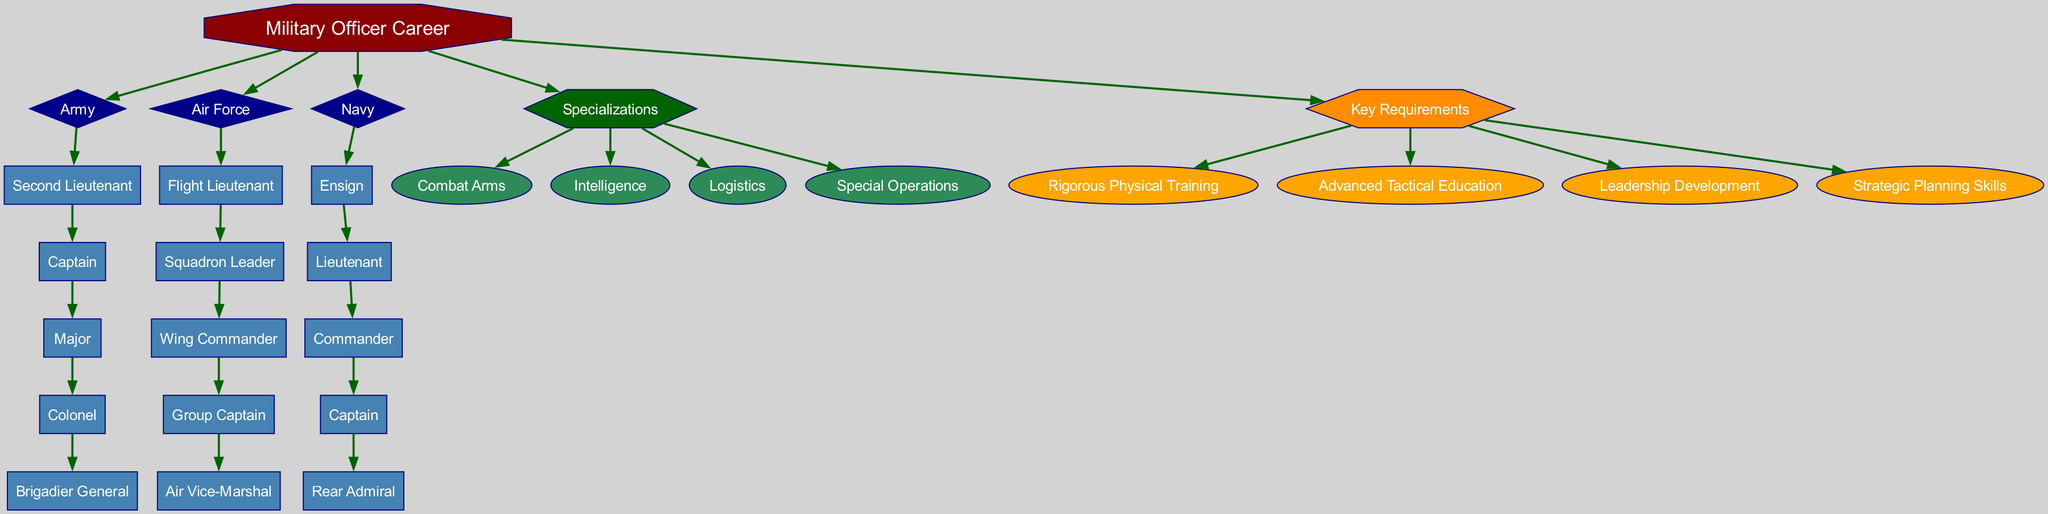What is the root node of the diagram? The diagram's root node is "Military Officer Career," which represents the overarching theme of the career paths depicted.
Answer: Military Officer Career How many branches are there in the diagram? The diagram contains three main branches: Army, Air Force, and Navy, representing different military branches.
Answer: 3 What is the highest rank in the Army branch? In the Army branch, the highest rank listed is "Brigadier General," which is the last rank in the Army's hierarchy.
Answer: Brigadier General Which specialization is associated with the diagram? The diagram lists several specializations, and one of them, for instance, is "Combat Arms," indicating different areas of expertise within military officer careers.
Answer: Combat Arms What shape represents the key requirements in the diagram? The key requirements are represented by a hexagon shape, which distinctly indicates it as a category of important factors for officer progression.
Answer: Hexagon How many ranks are listed under the Navy branch? The Navy branch includes five ranks: Ensign, Lieutenant, Commander, Captain, and Rear Admiral, showcasing the career progression available in naval service.
Answer: 5 What is the color of the ranks in the Army branch? The ranks in the Army branch are filled with "steelblue," a specific color chosen to represent ranks distinctly in the diagram.
Answer: Steelblue Which requirement emphasizes leadership skills? The requirement "Leadership Development" focuses on cultivating leadership skills necessary for career advancement in the military.
Answer: Leadership Development What does the diamond shape signify in the diagram? The diamond shape signifies the branches of service, which are fundamental components of the diagram's structure, clearly categorizing different military paths.
Answer: Branches of Service 